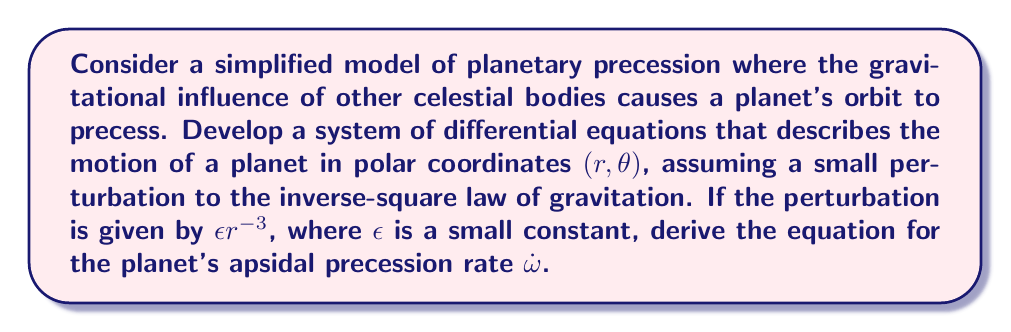Solve this math problem. Let's approach this step-by-step:

1) In polar coordinates, the equations of motion for a central force are:

   $$\ddot{r} - r\dot{\theta}^2 = -\frac{\partial U}{\partial r}$$
   $$\frac{1}{r}\frac{d}{dt}(r^2\dot{\theta}) = 0$$

2) The perturbed gravitational potential is:

   $$U(r) = -\frac{GM}{r} - \frac{\epsilon}{2r^2}$$

3) From the second equation of motion, we get the conservation of angular momentum:

   $$r^2\dot{\theta} = h = \text{constant}$$

4) Substituting this into the first equation:

   $$\ddot{r} - \frac{h^2}{r^3} = -\frac{GM}{r^2} + \frac{\epsilon}{r^3}$$

5) To solve this, we use the substitution $u = \frac{1}{r}$. This gives:

   $$\frac{d^2u}{d\theta^2} + u = \frac{GM}{h^2} + \frac{\epsilon}{h^2}u^2$$

6) For small perturbations, we can use the method of successive approximations. Let $u = u_0 + \epsilon u_1$, where $u_0$ is the unperturbed solution:

   $$u_0 = \frac{GM}{h^2}(1 + e\cos\theta)$$

7) Substituting this into the differential equation and keeping only first-order terms in $\epsilon$:

   $$\frac{d^2u_1}{d\theta^2} + u_1 = \frac{1}{h^2}u_0^2$$

8) The solution to this equation includes a secular term:

   $$u_1 = \frac{GM}{2h^4}(1 + e\cos\theta)^2\theta\sin\theta + \text{periodic terms}$$

9) The secular term causes the apsides to precess. The precession rate is given by:

   $$\dot{\omega} = \frac{\epsilon}{h} = \frac{\epsilon}{r^2\dot{\theta}}$$

10) For nearly circular orbits, we can approximate $r \approx a$ (semi-major axis) and $\dot{\theta} \approx n$ (mean motion). This gives:

    $$\dot{\omega} \approx \frac{\epsilon}{a^2n}$$

11) Using Kepler's third law, $n^2a^3 = GM$, we can express this in terms of the orbital period $T$:

    $$\dot{\omega} \approx \frac{2\pi\epsilon}{GMT}$$
Answer: $$\dot{\omega} \approx \frac{2\pi\epsilon}{GMT}$$ 